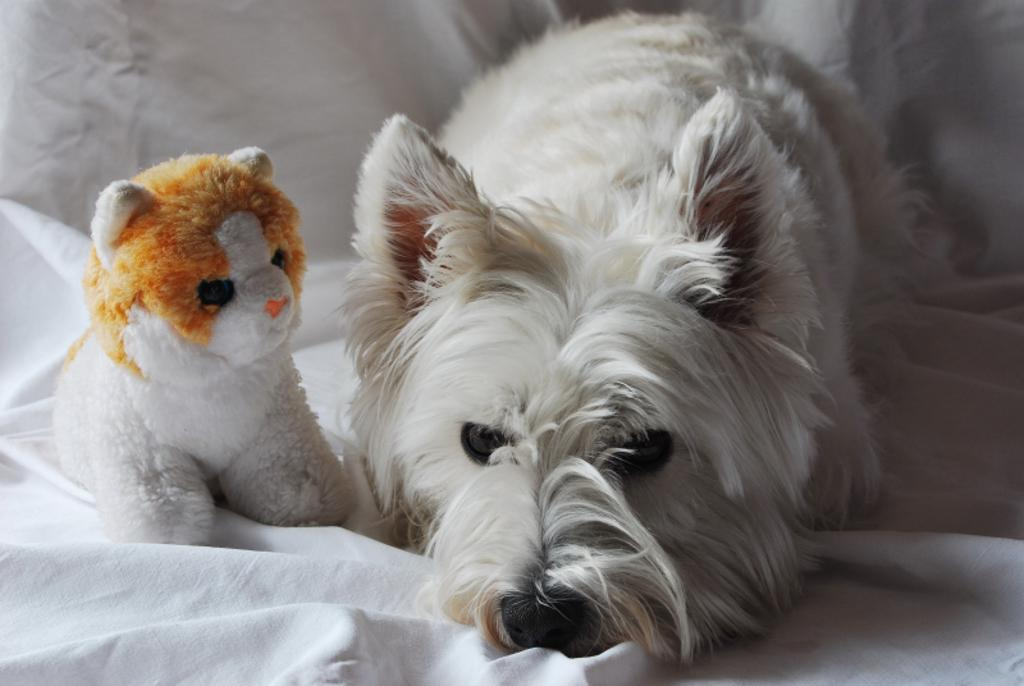What type of animal is present in the image? There is a dog in the image. What other object can be seen in the image? There is a toy in the image. Where are the dog and the toy located in the image? Both the dog and the toy are on a bed. What type of nut is the dog trying to crack open in the image? There is no nut present in the image; it features a dog and a toy on a bed. What type of authority figure is present in the image? There is no authority figure present in the image; it features a dog and a toy on a bed. 